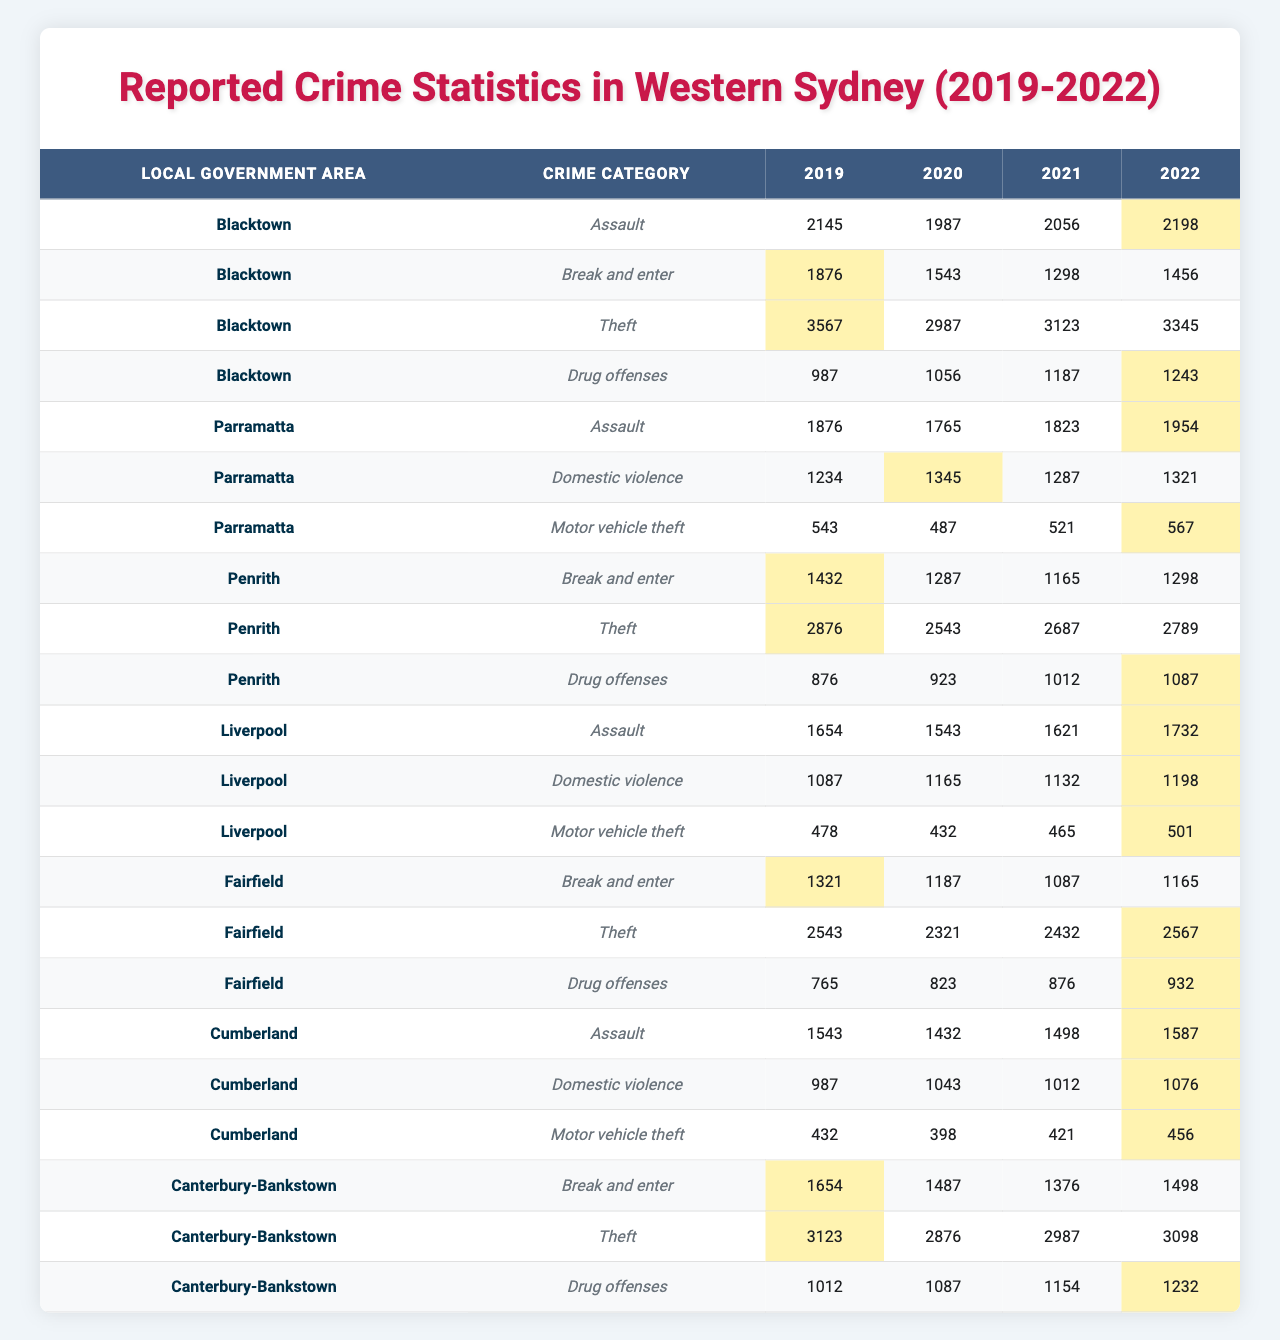What is the total number of assaults reported in Blacktown from 2019 to 2022? To find the total assaults in Blacktown, we add the numbers for each year: 2145 (2019) + 1987 (2020) + 2056 (2021) + 2198 (2022) = 8386.
Answer: 8386 Which year had the highest number of thefts in Liverpool? Looking at the theft data for Liverpool over the years: 2019 had 1654, 2020 had 1543, 2021 had 1621, and 2022 had 1732. The highest value is in 2022.
Answer: 2022 How many drug offenses were reported in total in Penrith from 2019 to 2022? We can find the total by summing all the reported drug offenses in Penrith: 876 (2019) + 923 (2020) + 1012 (2021) + 1087 (2022) = 3898.
Answer: 3898 Did the number of break and enter incidents increase or decrease in Canterbury-Bankstown from 2019 to 2022? By comparing the values of break and enter incidents for Canterbury-Bankstown: 1654 (2019) decreased to 1487 (2020), then further decreased to 1376 (2021), but increased to 1498 (2022). Overall, the incidents increased compared to 2021.
Answer: Yes, it increased What was the average number of reported domestic violence incidents in Parramatta over the years? To calculate the average, we sum the incidents: 1234 (2019) + 1345 (2020) + 1287 (2021) + 1321 (2022) = 5187. Then divide by the number of years (4): 5187 / 4 = 1296.75, rounding to 1297.
Answer: 1297 Which local government area had the least number of motor vehicle thefts in 2022? Checking the 2022 data for motor vehicle thefts: Liverpool had 501, Blacktown had none listed, Parramatta had 567, Cumberland had 456, Fairfield had none listed, and Canterbury-Bankstown had none listed. The least among those reported is Cumberland with 456.
Answer: Cumberland In which year did the most break and enters occur in Blacktown? The break and enter incidents for Blacktown over the years are: 1876 (2019), 1543 (2020), 1298 (2021), and 1456 (2022). The highest is 1876 in 2019.
Answer: 2019 Were there more drug offenses reported in Fairfield than in Liverpool in 2021? In 2021, Fairfield reported 876 drug offenses while Liverpool reported 1012. Comparing these, Liverpool had more offenses than Fairfield.
Answer: No What was the percentage increase in assaults in Blacktown from 2021 to 2022? The number of assaults in 2021 was 2056 and in 2022 it was 2198. First, calculate the difference: 2198 - 2056 = 142. Next, divide by the original number (2056) and multiply by 100 to get the percentage: (142 / 2056) * 100 ≈ 6.9%.
Answer: 6.9% Which local government area had the highest number of thefts in 2021? Looking at the theft numbers for 2021: Blacktown had 3123, Penrith had 2687, Fairfield had 2432, Canterbury-Bankstown had 2987, and Liverpool had 1654. The highest is Blacktown with 3123.
Answer: Blacktown 